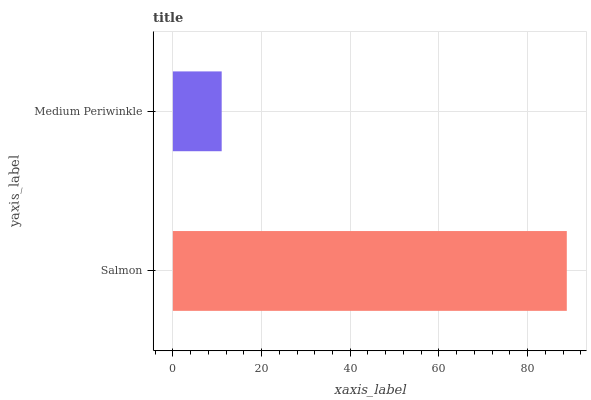Is Medium Periwinkle the minimum?
Answer yes or no. Yes. Is Salmon the maximum?
Answer yes or no. Yes. Is Medium Periwinkle the maximum?
Answer yes or no. No. Is Salmon greater than Medium Periwinkle?
Answer yes or no. Yes. Is Medium Periwinkle less than Salmon?
Answer yes or no. Yes. Is Medium Periwinkle greater than Salmon?
Answer yes or no. No. Is Salmon less than Medium Periwinkle?
Answer yes or no. No. Is Salmon the high median?
Answer yes or no. Yes. Is Medium Periwinkle the low median?
Answer yes or no. Yes. Is Medium Periwinkle the high median?
Answer yes or no. No. Is Salmon the low median?
Answer yes or no. No. 